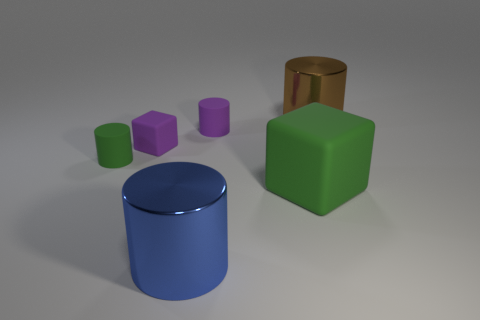Add 3 tiny objects. How many objects exist? 9 Subtract all cubes. How many objects are left? 4 Add 3 big brown metallic objects. How many big brown metallic objects exist? 4 Subtract 1 blue cylinders. How many objects are left? 5 Subtract all small red shiny cubes. Subtract all purple matte blocks. How many objects are left? 5 Add 3 tiny rubber cylinders. How many tiny rubber cylinders are left? 5 